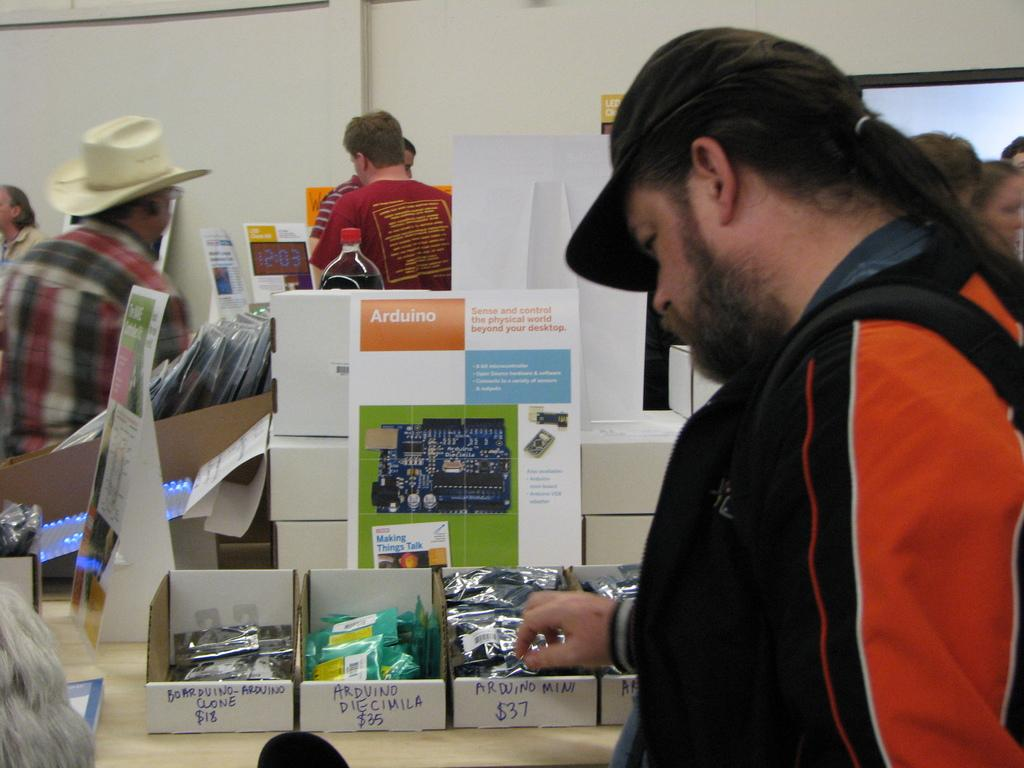What are the people in the image doing? The people are standing in the image. Where are the people standing in relation to the table? The people are standing in front of a table. What can be seen on the table in the image? There are items placed on the table. What is visible in the background of the image? There is a wall in the background of the image. What type of liquid is being poured from the lamp in the image? There is no lamp or liquid present in the image. 